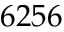<formula> <loc_0><loc_0><loc_500><loc_500>6 2 5 6</formula> 